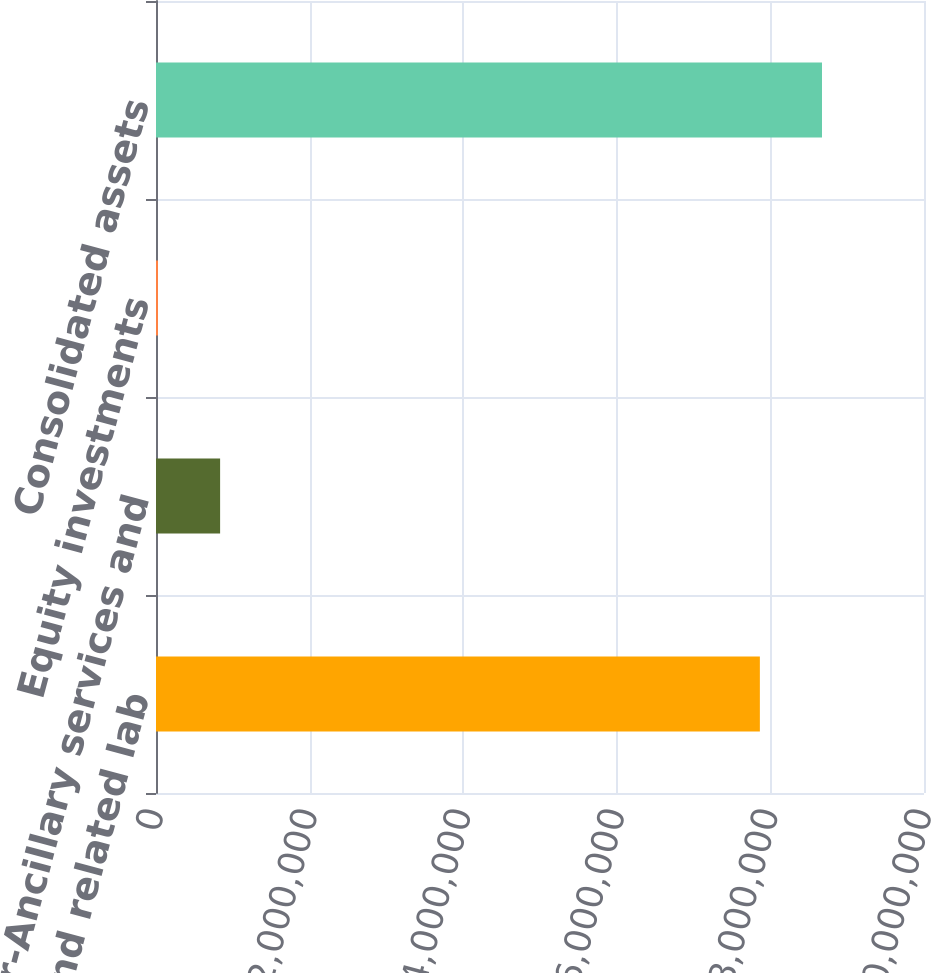<chart> <loc_0><loc_0><loc_500><loc_500><bar_chart><fcel>Dialysis and related lab<fcel>Other-Ancillary services and<fcel>Equity investments<fcel>Consolidated assets<nl><fcel>7.86288e+06<fcel>834769<fcel>25918<fcel>8.67173e+06<nl></chart> 